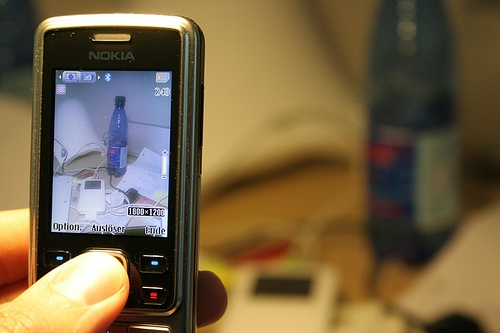Describe the objects in this image and their specific colors. I can see cell phone in black, darkgray, lavender, and gray tones, bottle in black, darkgreen, and maroon tones, people in black, khaki, beige, gold, and maroon tones, and bottle in black, blue, purple, and darkblue tones in this image. 